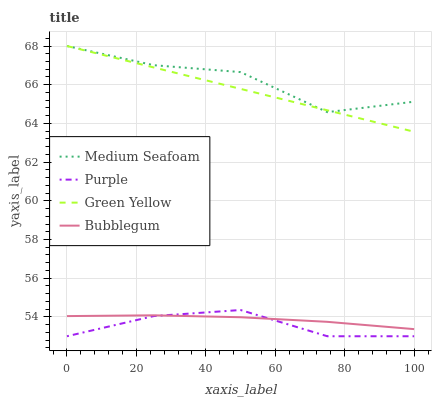Does Purple have the minimum area under the curve?
Answer yes or no. Yes. Does Medium Seafoam have the maximum area under the curve?
Answer yes or no. Yes. Does Green Yellow have the minimum area under the curve?
Answer yes or no. No. Does Green Yellow have the maximum area under the curve?
Answer yes or no. No. Is Green Yellow the smoothest?
Answer yes or no. Yes. Is Medium Seafoam the roughest?
Answer yes or no. Yes. Is Medium Seafoam the smoothest?
Answer yes or no. No. Is Green Yellow the roughest?
Answer yes or no. No. Does Purple have the lowest value?
Answer yes or no. Yes. Does Green Yellow have the lowest value?
Answer yes or no. No. Does Medium Seafoam have the highest value?
Answer yes or no. Yes. Does Bubblegum have the highest value?
Answer yes or no. No. Is Purple less than Green Yellow?
Answer yes or no. Yes. Is Medium Seafoam greater than Bubblegum?
Answer yes or no. Yes. Does Purple intersect Bubblegum?
Answer yes or no. Yes. Is Purple less than Bubblegum?
Answer yes or no. No. Is Purple greater than Bubblegum?
Answer yes or no. No. Does Purple intersect Green Yellow?
Answer yes or no. No. 